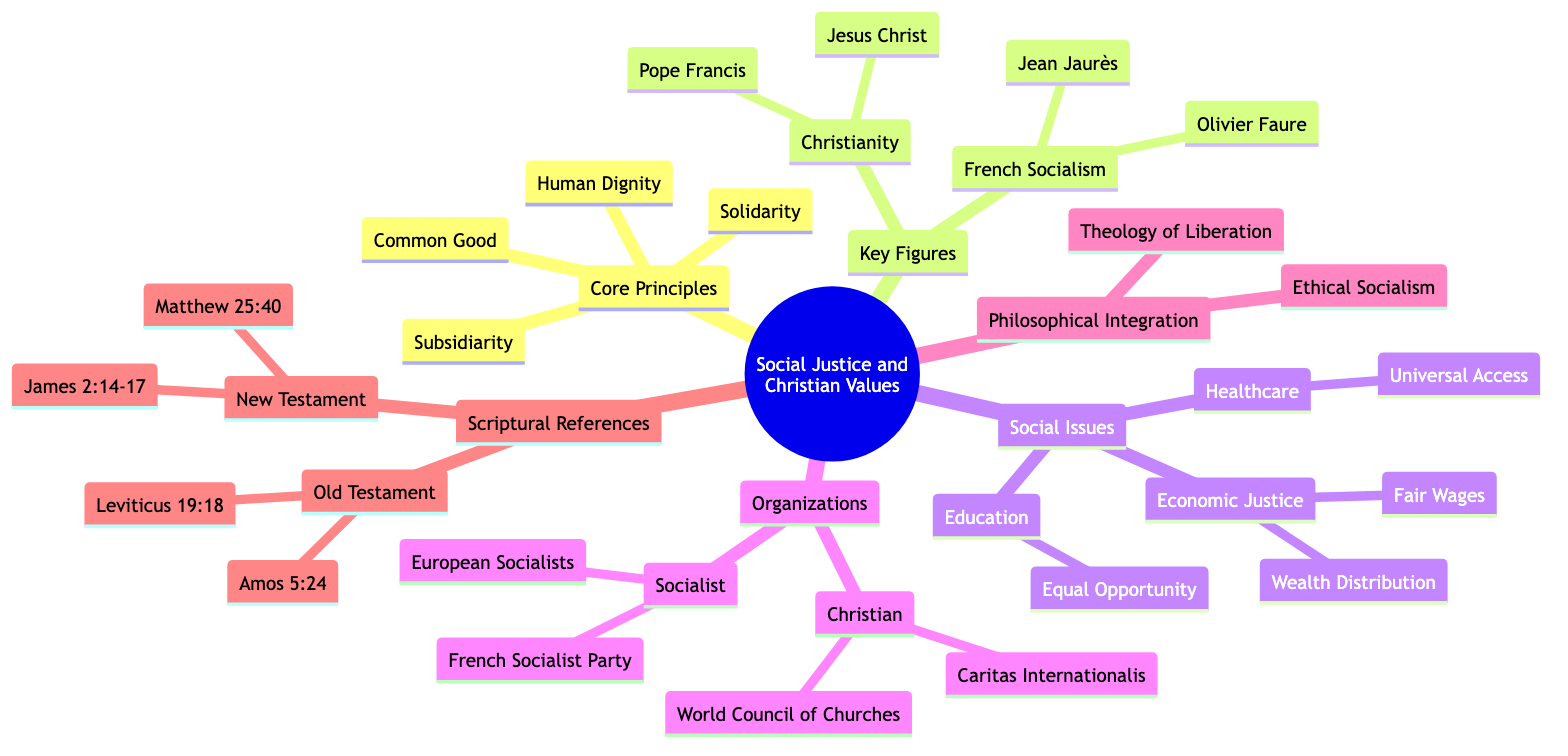What are the core principles outlined in the diagram? The diagram lists four core principles under the "Core Principles" node: Human Dignity, Common Good, Solidarity, and Subsidiarity.
Answer: Human Dignity, Common Good, Solidarity, Subsidiarity Who is the current leader of the French Socialist Party? The "French Socialism" section includes key figures, and it specifies Olivier Faure as the current leader of the French Socialist Party.
Answer: Olivier Faure How many organizations are listed under "Organizations"? The "Organizations" section includes two subdivisions: "Christian" and "Socialist," each containing two organizations, totaling four organizations.
Answer: 4 What does the "Theology of Liberation" fall under? The "Philosophical Integration" node contains two frameworks, one of which is "Theology of Liberation."
Answer: Philosophical Integration Which scriptural reference emphasizes action in social justice? The "New Testament" portion of "Scriptural References" includes James 2:14-17, which highlights the importance of action in relation to faith.
Answer: James 2:14-17 What key figure is associated with advocating for social justice in Christianity? According to the "Key Figures" section, Pope Francis is noted for his advocacy for social justice and economic equality.
Answer: Pope Francis What is the relationship between Fair Wages and Human Dignity in the diagram? Both Fair Wages and Human Dignity are part of the Economic Justice section, indicating that Fair Wages supports the Christian teaching of Human Dignity regarding labor rights.
Answer: Supports Which organization supports social justice globally among Christians? Under the "Christian" organizations, Caritas Internationalis is mentioned as a humanitarian organization supporting social justice globally.
Answer: Caritas Internationalis How many scriptural references are listed in total? The diagram provides two scriptural references from the Old Testament and two from the New Testament, totaling four references.
Answer: 4 